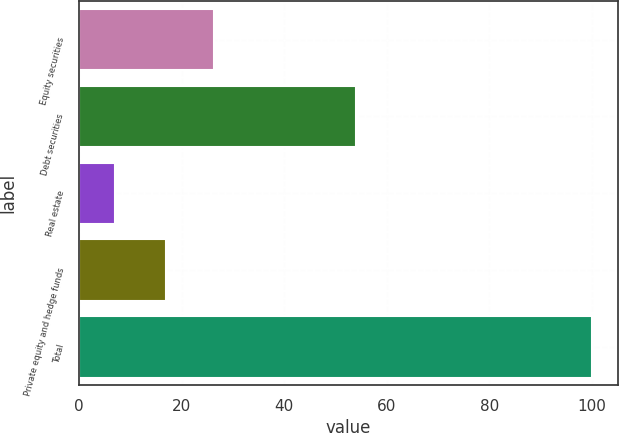Convert chart to OTSL. <chart><loc_0><loc_0><loc_500><loc_500><bar_chart><fcel>Equity securities<fcel>Debt securities<fcel>Real estate<fcel>Private equity and hedge funds<fcel>Total<nl><fcel>26.3<fcel>54<fcel>7<fcel>17<fcel>100<nl></chart> 